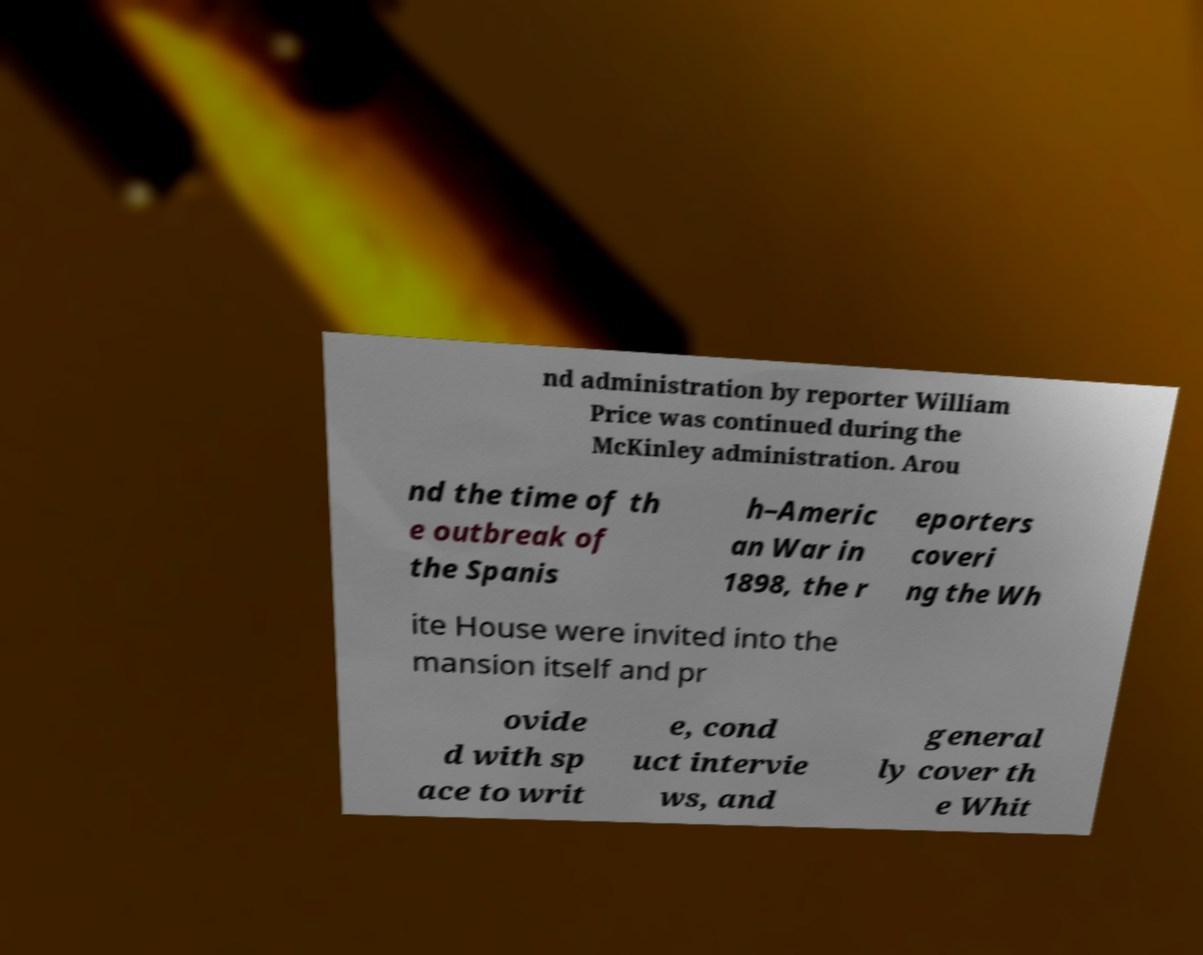There's text embedded in this image that I need extracted. Can you transcribe it verbatim? nd administration by reporter William Price was continued during the McKinley administration. Arou nd the time of th e outbreak of the Spanis h–Americ an War in 1898, the r eporters coveri ng the Wh ite House were invited into the mansion itself and pr ovide d with sp ace to writ e, cond uct intervie ws, and general ly cover th e Whit 